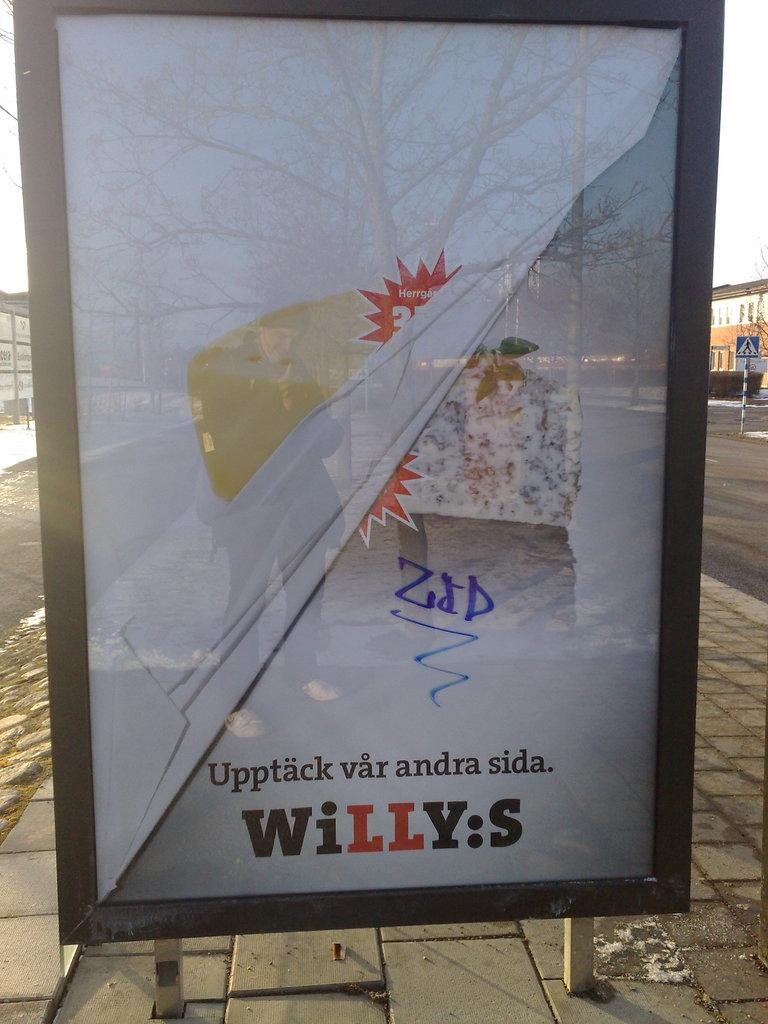<image>
Offer a succinct explanation of the picture presented. Board at a bus stop that says "Willys" on it. 